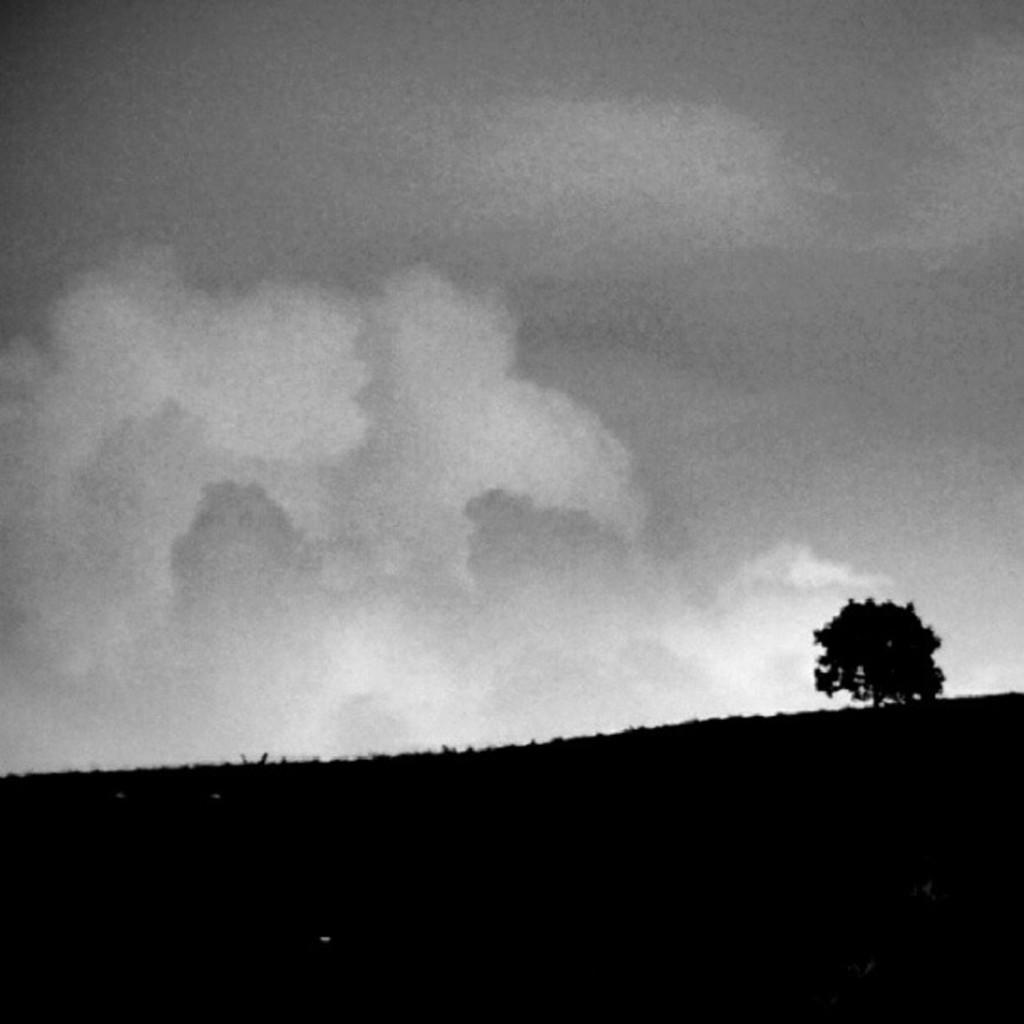Could you give a brief overview of what you see in this image? This is an edited picture. At the bottom it is looking like there are trees. At the top there is sky. 